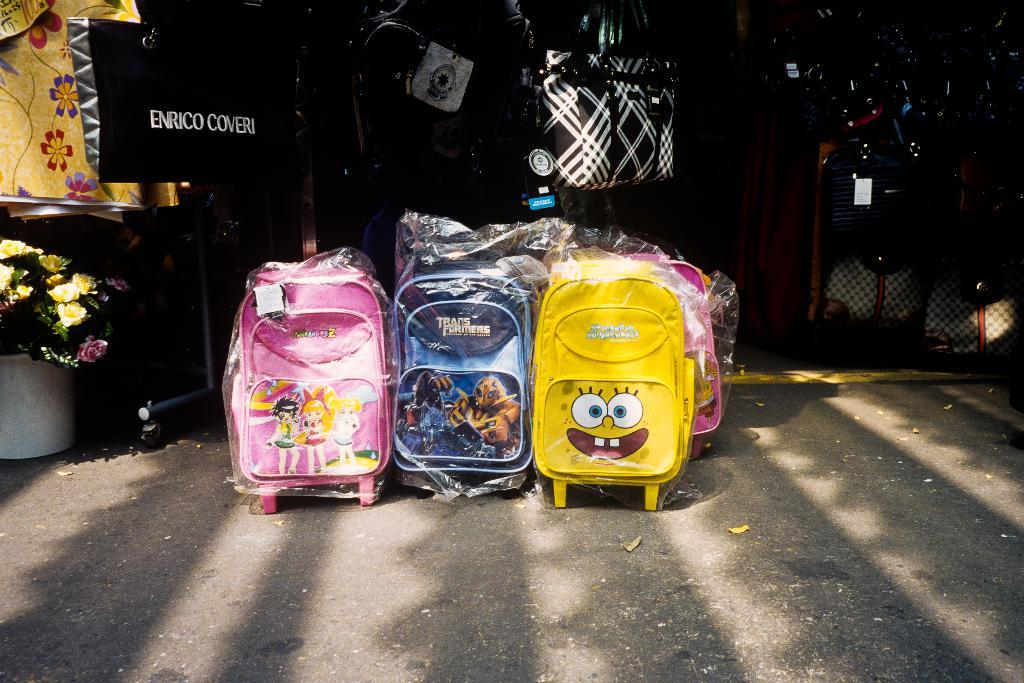What is on the floor in the image? There are bags on the floor in the image. What type of plant can be seen in the image? There is a houseplant in the image. What material is present in the image? There are boards in the image. How are some of the bags positioned in the image? Some bags are hanged in the image. What type of establishment is visible in the image? There is a shop in the image. Where is the image likely taken? The image is likely taken near a shop. What type of zebra can be seen near the shop in the image? There is no zebra present in the image; it is a shop with bags and a houseplant. Is there a volcano visible in the image? No, there is no volcano present in the image. 